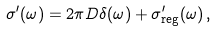<formula> <loc_0><loc_0><loc_500><loc_500>\sigma ^ { \prime } ( \omega ) = 2 \pi D \delta ( \omega ) + \sigma ^ { \prime } _ { \text {reg} } ( \omega ) \, ,</formula> 